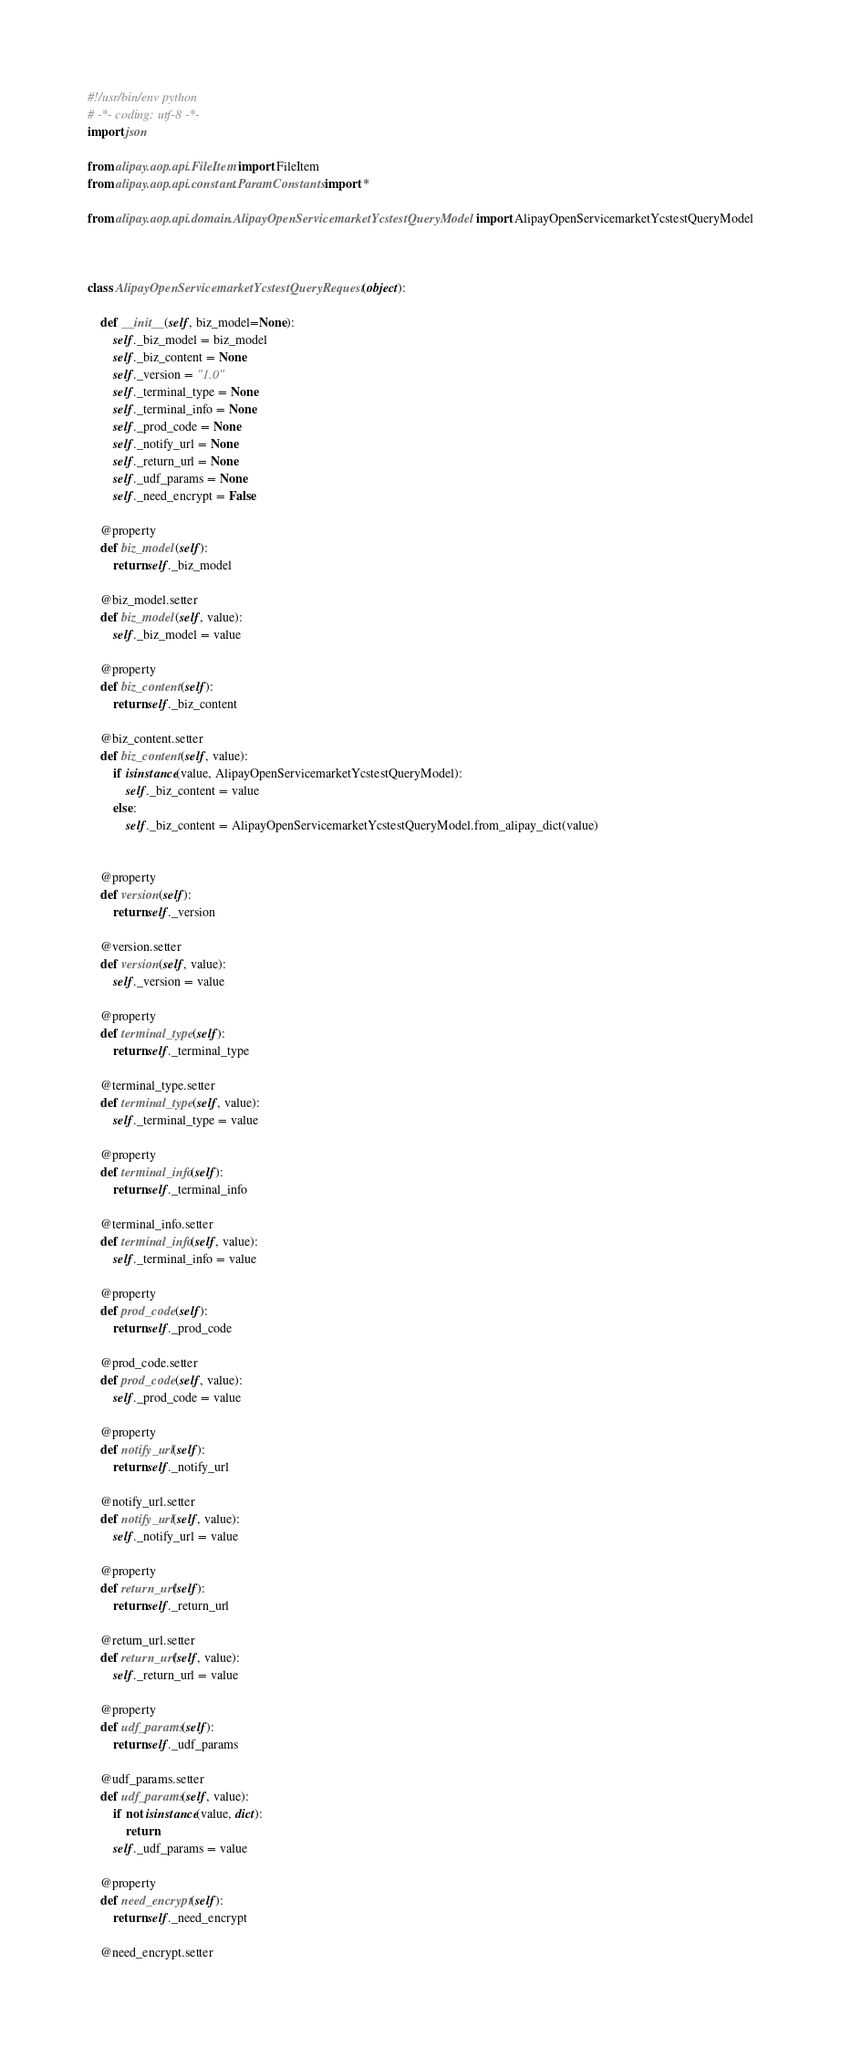<code> <loc_0><loc_0><loc_500><loc_500><_Python_>#!/usr/bin/env python
# -*- coding: utf-8 -*-
import json

from alipay.aop.api.FileItem import FileItem
from alipay.aop.api.constant.ParamConstants import *

from alipay.aop.api.domain.AlipayOpenServicemarketYcstestQueryModel import AlipayOpenServicemarketYcstestQueryModel



class AlipayOpenServicemarketYcstestQueryRequest(object):

    def __init__(self, biz_model=None):
        self._biz_model = biz_model
        self._biz_content = None
        self._version = "1.0"
        self._terminal_type = None
        self._terminal_info = None
        self._prod_code = None
        self._notify_url = None
        self._return_url = None
        self._udf_params = None
        self._need_encrypt = False

    @property
    def biz_model(self):
        return self._biz_model

    @biz_model.setter
    def biz_model(self, value):
        self._biz_model = value

    @property
    def biz_content(self):
        return self._biz_content

    @biz_content.setter
    def biz_content(self, value):
        if isinstance(value, AlipayOpenServicemarketYcstestQueryModel):
            self._biz_content = value
        else:
            self._biz_content = AlipayOpenServicemarketYcstestQueryModel.from_alipay_dict(value)


    @property
    def version(self):
        return self._version

    @version.setter
    def version(self, value):
        self._version = value

    @property
    def terminal_type(self):
        return self._terminal_type

    @terminal_type.setter
    def terminal_type(self, value):
        self._terminal_type = value

    @property
    def terminal_info(self):
        return self._terminal_info

    @terminal_info.setter
    def terminal_info(self, value):
        self._terminal_info = value

    @property
    def prod_code(self):
        return self._prod_code

    @prod_code.setter
    def prod_code(self, value):
        self._prod_code = value

    @property
    def notify_url(self):
        return self._notify_url

    @notify_url.setter
    def notify_url(self, value):
        self._notify_url = value

    @property
    def return_url(self):
        return self._return_url

    @return_url.setter
    def return_url(self, value):
        self._return_url = value

    @property
    def udf_params(self):
        return self._udf_params

    @udf_params.setter
    def udf_params(self, value):
        if not isinstance(value, dict):
            return
        self._udf_params = value

    @property
    def need_encrypt(self):
        return self._need_encrypt

    @need_encrypt.setter</code> 